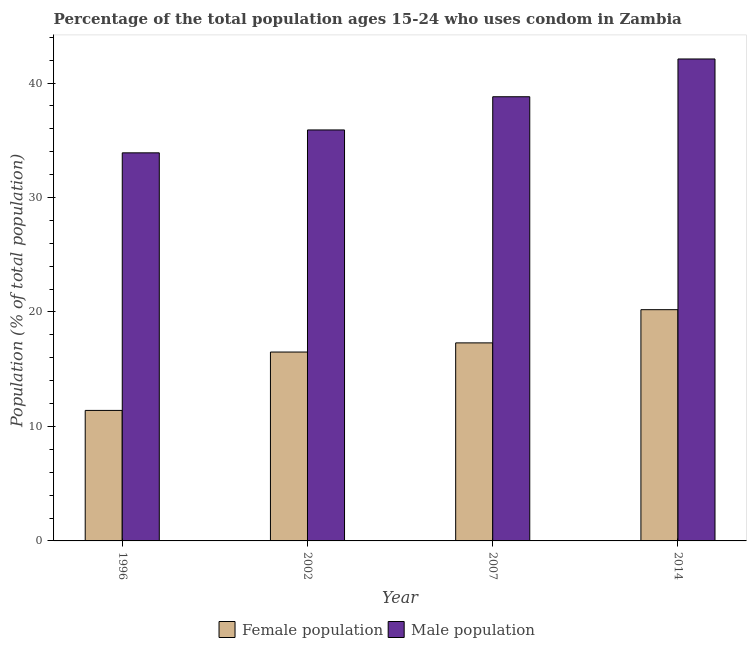How many different coloured bars are there?
Offer a very short reply. 2. Are the number of bars per tick equal to the number of legend labels?
Keep it short and to the point. Yes. Are the number of bars on each tick of the X-axis equal?
Your answer should be compact. Yes. How many bars are there on the 3rd tick from the left?
Your response must be concise. 2. In how many cases, is the number of bars for a given year not equal to the number of legend labels?
Your answer should be compact. 0. Across all years, what is the maximum male population?
Your answer should be very brief. 42.1. Across all years, what is the minimum male population?
Your answer should be very brief. 33.9. In which year was the female population minimum?
Ensure brevity in your answer.  1996. What is the total female population in the graph?
Provide a short and direct response. 65.4. What is the difference between the male population in 1996 and that in 2002?
Your response must be concise. -2. What is the difference between the male population in 2014 and the female population in 1996?
Your response must be concise. 8.2. What is the average female population per year?
Offer a very short reply. 16.35. In the year 2002, what is the difference between the male population and female population?
Provide a short and direct response. 0. What is the ratio of the female population in 1996 to that in 2007?
Provide a short and direct response. 0.66. What is the difference between the highest and the second highest male population?
Provide a succinct answer. 3.3. What is the difference between the highest and the lowest female population?
Your answer should be compact. 8.8. In how many years, is the male population greater than the average male population taken over all years?
Give a very brief answer. 2. Is the sum of the female population in 1996 and 2002 greater than the maximum male population across all years?
Provide a succinct answer. Yes. What does the 1st bar from the left in 2007 represents?
Ensure brevity in your answer.  Female population. What does the 1st bar from the right in 2014 represents?
Your answer should be compact. Male population. How many bars are there?
Your response must be concise. 8. Are all the bars in the graph horizontal?
Your response must be concise. No. What is the difference between two consecutive major ticks on the Y-axis?
Provide a succinct answer. 10. Does the graph contain any zero values?
Offer a very short reply. No. How many legend labels are there?
Provide a succinct answer. 2. What is the title of the graph?
Ensure brevity in your answer.  Percentage of the total population ages 15-24 who uses condom in Zambia. What is the label or title of the X-axis?
Your answer should be compact. Year. What is the label or title of the Y-axis?
Give a very brief answer. Population (% of total population) . What is the Population (% of total population)  in Female population in 1996?
Give a very brief answer. 11.4. What is the Population (% of total population)  in Male population in 1996?
Provide a short and direct response. 33.9. What is the Population (% of total population)  in Male population in 2002?
Your answer should be very brief. 35.9. What is the Population (% of total population)  of Female population in 2007?
Offer a very short reply. 17.3. What is the Population (% of total population)  in Male population in 2007?
Your response must be concise. 38.8. What is the Population (% of total population)  in Female population in 2014?
Offer a terse response. 20.2. What is the Population (% of total population)  in Male population in 2014?
Give a very brief answer. 42.1. Across all years, what is the maximum Population (% of total population)  in Female population?
Offer a very short reply. 20.2. Across all years, what is the maximum Population (% of total population)  in Male population?
Offer a terse response. 42.1. Across all years, what is the minimum Population (% of total population)  of Male population?
Ensure brevity in your answer.  33.9. What is the total Population (% of total population)  in Female population in the graph?
Offer a terse response. 65.4. What is the total Population (% of total population)  in Male population in the graph?
Give a very brief answer. 150.7. What is the difference between the Population (% of total population)  in Female population in 1996 and that in 2002?
Ensure brevity in your answer.  -5.1. What is the difference between the Population (% of total population)  in Male population in 1996 and that in 2002?
Your answer should be very brief. -2. What is the difference between the Population (% of total population)  of Male population in 1996 and that in 2007?
Ensure brevity in your answer.  -4.9. What is the difference between the Population (% of total population)  in Male population in 2002 and that in 2007?
Your response must be concise. -2.9. What is the difference between the Population (% of total population)  of Male population in 2007 and that in 2014?
Your answer should be very brief. -3.3. What is the difference between the Population (% of total population)  of Female population in 1996 and the Population (% of total population)  of Male population in 2002?
Your answer should be very brief. -24.5. What is the difference between the Population (% of total population)  in Female population in 1996 and the Population (% of total population)  in Male population in 2007?
Keep it short and to the point. -27.4. What is the difference between the Population (% of total population)  in Female population in 1996 and the Population (% of total population)  in Male population in 2014?
Keep it short and to the point. -30.7. What is the difference between the Population (% of total population)  of Female population in 2002 and the Population (% of total population)  of Male population in 2007?
Ensure brevity in your answer.  -22.3. What is the difference between the Population (% of total population)  of Female population in 2002 and the Population (% of total population)  of Male population in 2014?
Keep it short and to the point. -25.6. What is the difference between the Population (% of total population)  of Female population in 2007 and the Population (% of total population)  of Male population in 2014?
Your answer should be very brief. -24.8. What is the average Population (% of total population)  in Female population per year?
Your response must be concise. 16.35. What is the average Population (% of total population)  in Male population per year?
Provide a succinct answer. 37.67. In the year 1996, what is the difference between the Population (% of total population)  in Female population and Population (% of total population)  in Male population?
Your response must be concise. -22.5. In the year 2002, what is the difference between the Population (% of total population)  of Female population and Population (% of total population)  of Male population?
Give a very brief answer. -19.4. In the year 2007, what is the difference between the Population (% of total population)  of Female population and Population (% of total population)  of Male population?
Make the answer very short. -21.5. In the year 2014, what is the difference between the Population (% of total population)  in Female population and Population (% of total population)  in Male population?
Provide a short and direct response. -21.9. What is the ratio of the Population (% of total population)  of Female population in 1996 to that in 2002?
Your answer should be very brief. 0.69. What is the ratio of the Population (% of total population)  in Male population in 1996 to that in 2002?
Provide a succinct answer. 0.94. What is the ratio of the Population (% of total population)  of Female population in 1996 to that in 2007?
Offer a terse response. 0.66. What is the ratio of the Population (% of total population)  of Male population in 1996 to that in 2007?
Ensure brevity in your answer.  0.87. What is the ratio of the Population (% of total population)  in Female population in 1996 to that in 2014?
Your response must be concise. 0.56. What is the ratio of the Population (% of total population)  of Male population in 1996 to that in 2014?
Your answer should be compact. 0.81. What is the ratio of the Population (% of total population)  in Female population in 2002 to that in 2007?
Keep it short and to the point. 0.95. What is the ratio of the Population (% of total population)  in Male population in 2002 to that in 2007?
Offer a terse response. 0.93. What is the ratio of the Population (% of total population)  of Female population in 2002 to that in 2014?
Your answer should be compact. 0.82. What is the ratio of the Population (% of total population)  of Male population in 2002 to that in 2014?
Your answer should be compact. 0.85. What is the ratio of the Population (% of total population)  in Female population in 2007 to that in 2014?
Offer a very short reply. 0.86. What is the ratio of the Population (% of total population)  in Male population in 2007 to that in 2014?
Give a very brief answer. 0.92. What is the difference between the highest and the second highest Population (% of total population)  of Female population?
Keep it short and to the point. 2.9. What is the difference between the highest and the second highest Population (% of total population)  of Male population?
Your answer should be very brief. 3.3. 